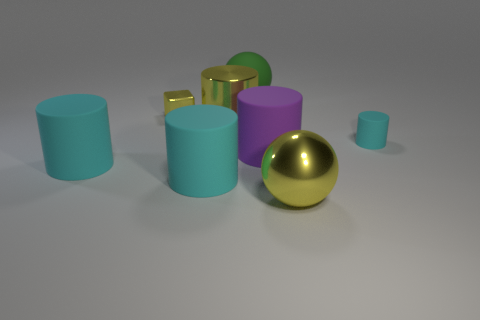Subtract all red cubes. How many cyan cylinders are left? 3 Subtract all small cyan rubber cylinders. How many cylinders are left? 4 Subtract all yellow cylinders. How many cylinders are left? 4 Subtract all red cylinders. Subtract all blue cubes. How many cylinders are left? 5 Add 2 big red rubber cylinders. How many objects exist? 10 Subtract all spheres. How many objects are left? 6 Add 6 big cylinders. How many big cylinders exist? 10 Subtract 0 blue balls. How many objects are left? 8 Subtract all small yellow blocks. Subtract all small yellow objects. How many objects are left? 6 Add 4 large green balls. How many large green balls are left? 5 